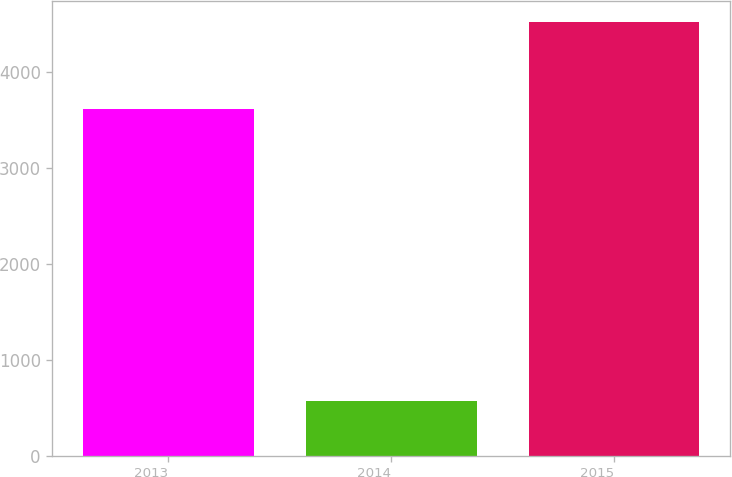Convert chart to OTSL. <chart><loc_0><loc_0><loc_500><loc_500><bar_chart><fcel>2013<fcel>2014<fcel>2015<nl><fcel>3612<fcel>572<fcel>4511<nl></chart> 